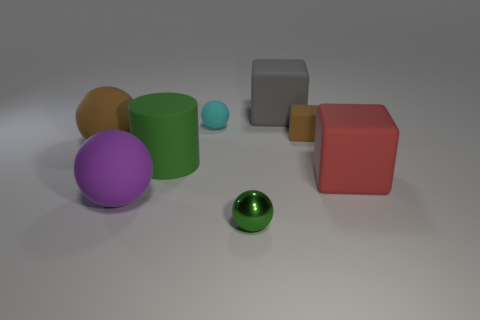There is another metal thing that is the same size as the cyan thing; what is its shape?
Offer a terse response. Sphere. Is there another small object that has the same shape as the gray rubber object?
Your answer should be very brief. Yes. Are the small thing left of the green metal ball and the green object that is in front of the large green cylinder made of the same material?
Offer a very short reply. No. What shape is the tiny thing that is the same color as the matte cylinder?
Your response must be concise. Sphere. What number of brown things are made of the same material as the big green thing?
Offer a very short reply. 2. What color is the large rubber cylinder?
Your response must be concise. Green. There is a green thing that is on the right side of the cylinder; does it have the same shape as the small object on the right side of the big gray cube?
Your answer should be very brief. No. There is a big rubber cube that is behind the big matte cylinder; what color is it?
Ensure brevity in your answer.  Gray. Is the number of tiny balls that are behind the big brown matte thing less than the number of green metal things that are in front of the big red thing?
Give a very brief answer. No. How many other things are there of the same material as the gray cube?
Provide a short and direct response. 6. 